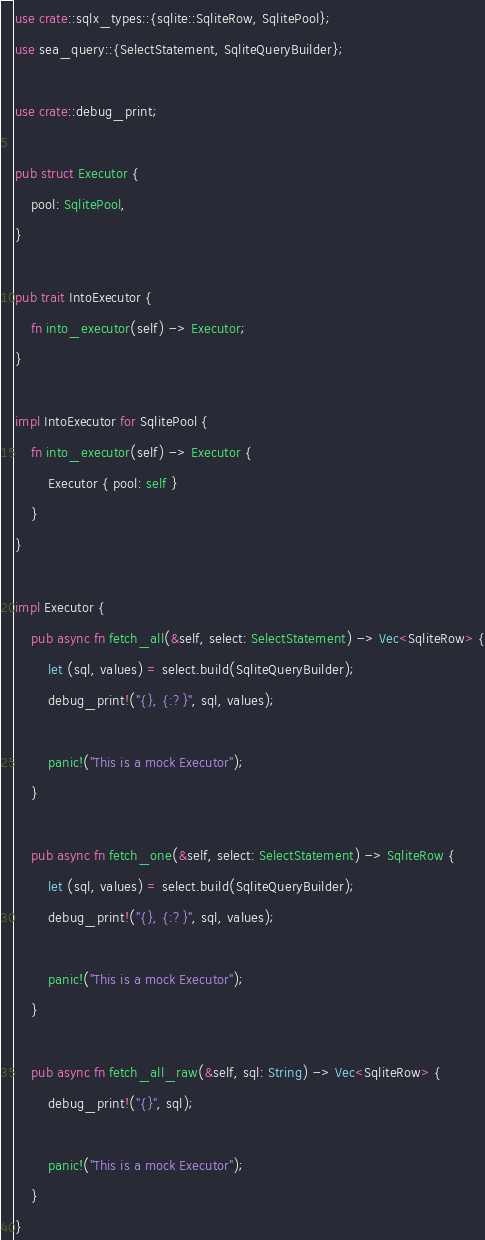<code> <loc_0><loc_0><loc_500><loc_500><_Rust_>use crate::sqlx_types::{sqlite::SqliteRow, SqlitePool};
use sea_query::{SelectStatement, SqliteQueryBuilder};

use crate::debug_print;

pub struct Executor {
    pool: SqlitePool,
}

pub trait IntoExecutor {
    fn into_executor(self) -> Executor;
}

impl IntoExecutor for SqlitePool {
    fn into_executor(self) -> Executor {
        Executor { pool: self }
    }
}

impl Executor {
    pub async fn fetch_all(&self, select: SelectStatement) -> Vec<SqliteRow> {
        let (sql, values) = select.build(SqliteQueryBuilder);
        debug_print!("{}, {:?}", sql, values);

        panic!("This is a mock Executor");
    }

    pub async fn fetch_one(&self, select: SelectStatement) -> SqliteRow {
        let (sql, values) = select.build(SqliteQueryBuilder);
        debug_print!("{}, {:?}", sql, values);

        panic!("This is a mock Executor");
    }

    pub async fn fetch_all_raw(&self, sql: String) -> Vec<SqliteRow> {
        debug_print!("{}", sql);

        panic!("This is a mock Executor");
    }
}
</code> 